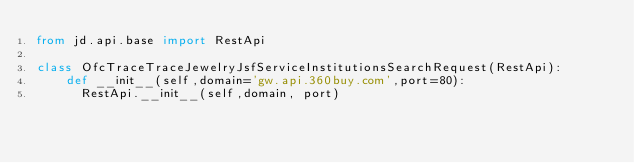Convert code to text. <code><loc_0><loc_0><loc_500><loc_500><_Python_>from jd.api.base import RestApi

class OfcTraceTraceJewelryJsfServiceInstitutionsSearchRequest(RestApi):
		def __init__(self,domain='gw.api.360buy.com',port=80):
			RestApi.__init__(self,domain, port)
</code> 